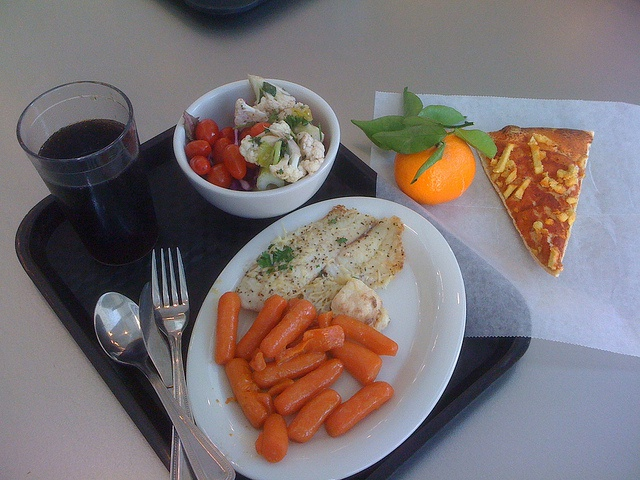Describe the objects in this image and their specific colors. I can see carrot in gray, brown, and maroon tones, bowl in gray, darkgray, and maroon tones, cup in gray and black tones, pizza in gray, brown, and tan tones, and spoon in gray, darkgray, and black tones in this image. 